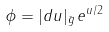<formula> <loc_0><loc_0><loc_500><loc_500>\phi = | d u | _ { \bar { g } } \, e ^ { u / 2 }</formula> 